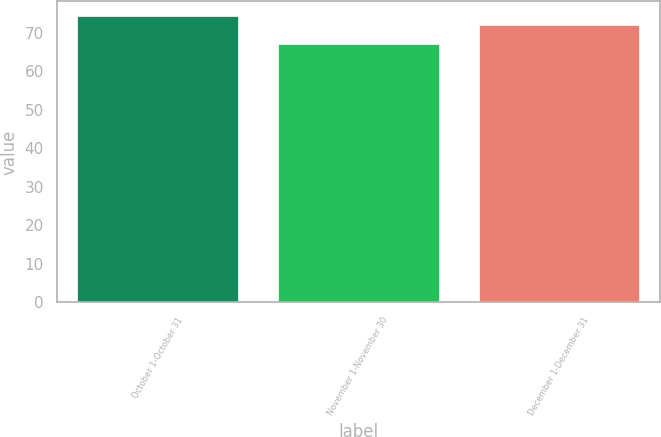Convert chart to OTSL. <chart><loc_0><loc_0><loc_500><loc_500><bar_chart><fcel>October 1-October 31<fcel>November 1-November 30<fcel>December 1-December 31<nl><fcel>74.43<fcel>67.09<fcel>72.16<nl></chart> 